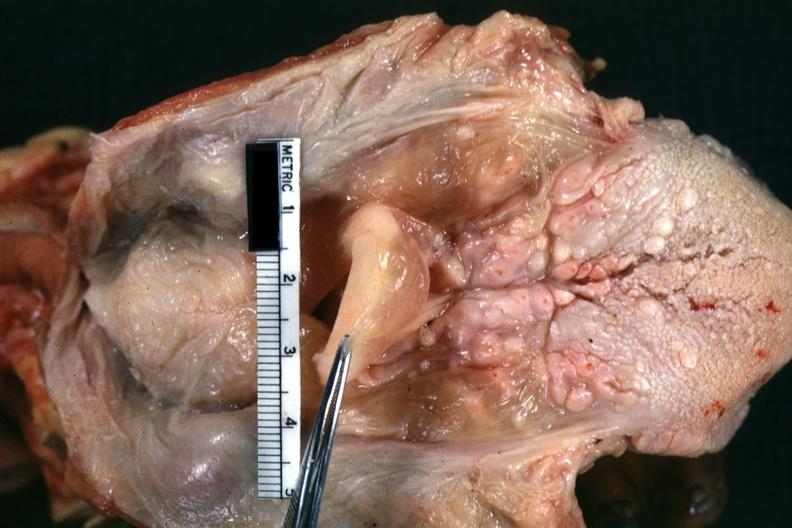what is present?
Answer the question using a single word or phrase. Hypopharyngeal edema 